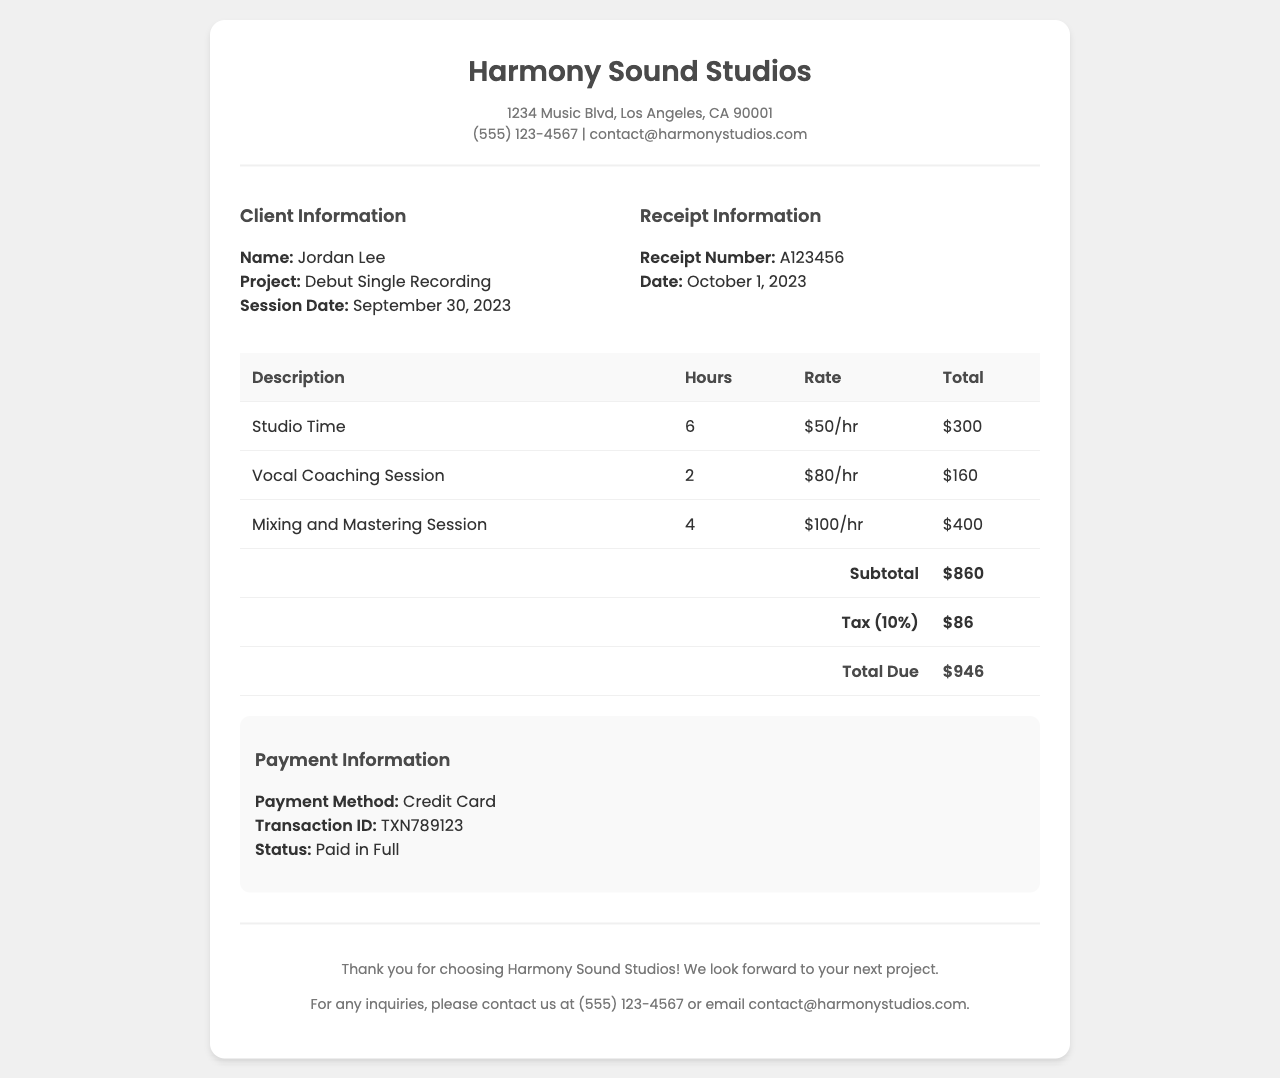What is the name of the client? The client's name is provided in the document as Jordan Lee.
Answer: Jordan Lee What is the session date? The document specifies the date of the recording session as September 30, 2023.
Answer: September 30, 2023 How many hours of studio time were rented? The breakdown of the services indicates that 6 hours of studio time were used.
Answer: 6 What is the total amount due? The total amount at the bottom of the receipt, including tax, is stated as $946.
Answer: $946 What was the rate for vocal coaching? The document lists the rate for vocal coaching sessions at $80 per hour.
Answer: $80/hr What is the subtotal before tax? The subtotal provided before tax is calculated as $860.
Answer: $860 How much is the tax charged? The invoice indicates that the tax charged is 10%, amounting to $86.
Answer: $86 What is the payment status? The document confirms the payment status is "Paid in Full."
Answer: Paid in Full What was the transaction ID? The transaction ID for the payment is given as TXN789123.
Answer: TXN789123 